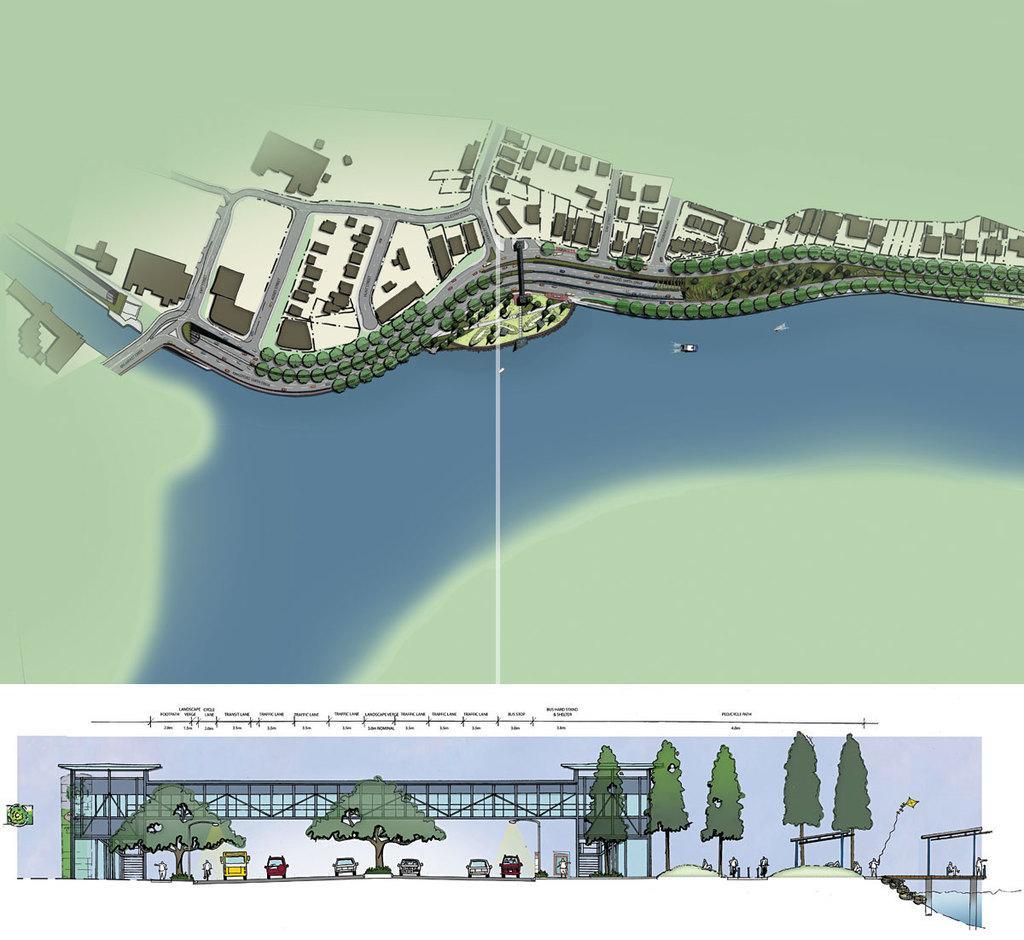Could you give a brief overview of what you see in this image? In this animated picture there is an aerial view on the land. Top of image there are few buildings, roads and trees. Middle of image there is water, beside there is land. Bottom of image there are few vehicles are under a bridge. There are few trees. 